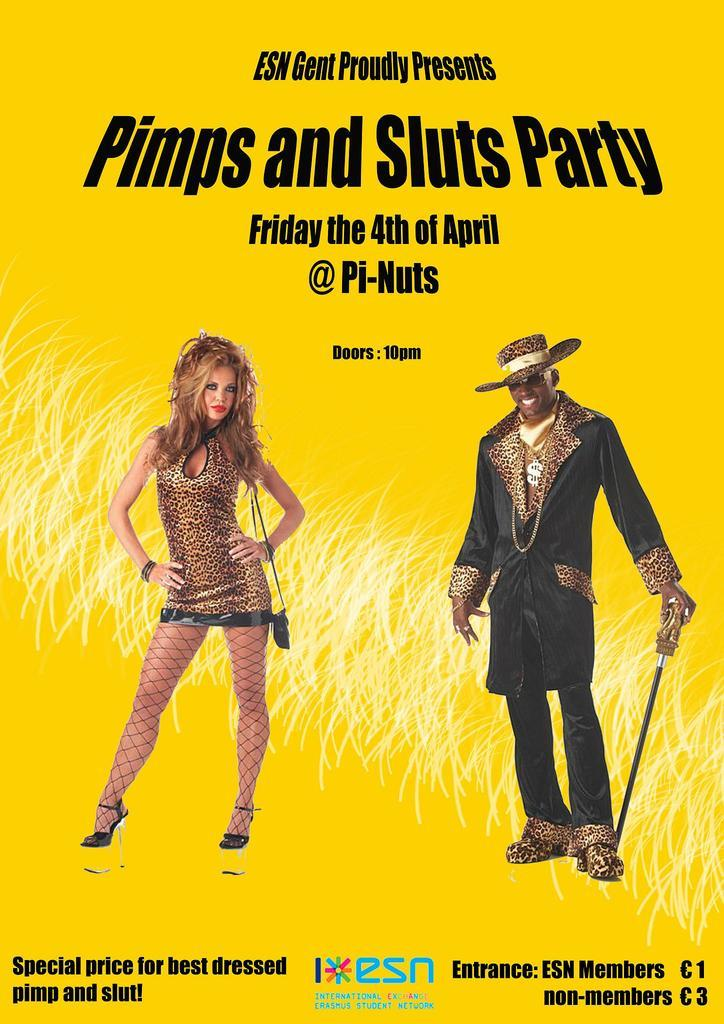What is present in the image that features an image of a person? There is a poster in the image that contains an image of a man and a woman. What else can be found on the poster besides the images of people? There is text on the poster. What type of noise can be heard coming from the poster in the image? There is no noise coming from the poster in the image, as it is a static visual representation. 